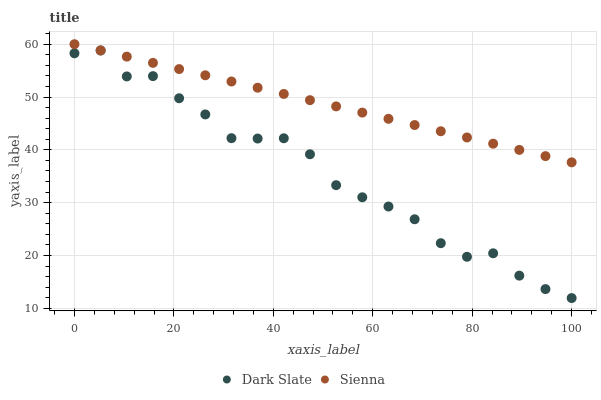Does Dark Slate have the minimum area under the curve?
Answer yes or no. Yes. Does Sienna have the maximum area under the curve?
Answer yes or no. Yes. Does Dark Slate have the maximum area under the curve?
Answer yes or no. No. Is Sienna the smoothest?
Answer yes or no. Yes. Is Dark Slate the roughest?
Answer yes or no. Yes. Is Dark Slate the smoothest?
Answer yes or no. No. Does Dark Slate have the lowest value?
Answer yes or no. Yes. Does Sienna have the highest value?
Answer yes or no. Yes. Does Dark Slate have the highest value?
Answer yes or no. No. Is Dark Slate less than Sienna?
Answer yes or no. Yes. Is Sienna greater than Dark Slate?
Answer yes or no. Yes. Does Dark Slate intersect Sienna?
Answer yes or no. No. 